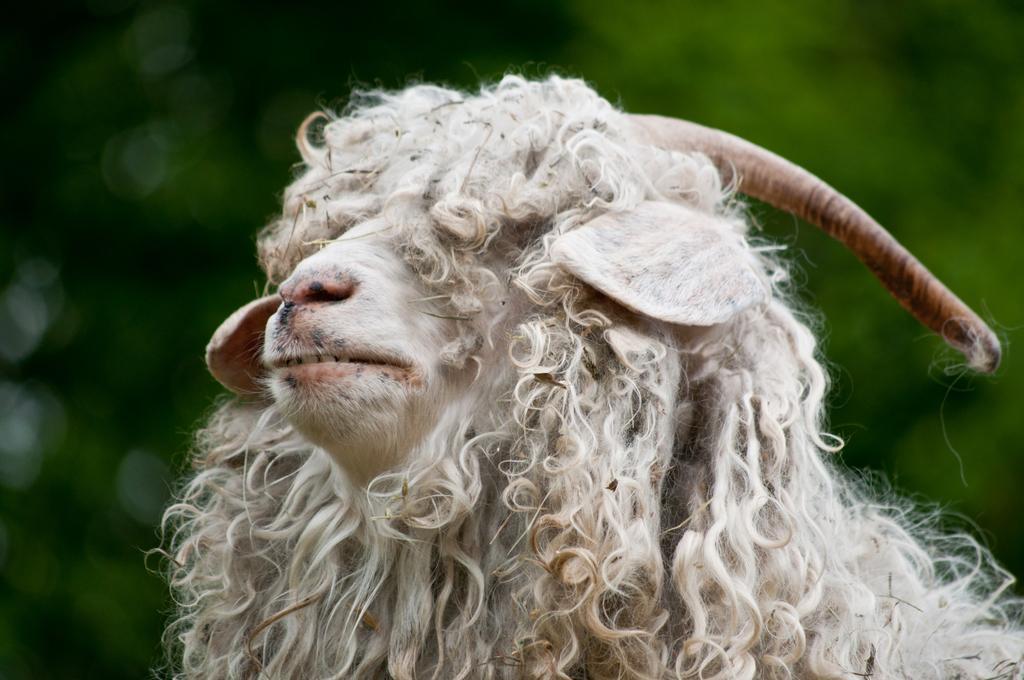Please provide a concise description of this image. In this image we can see a sheep. 